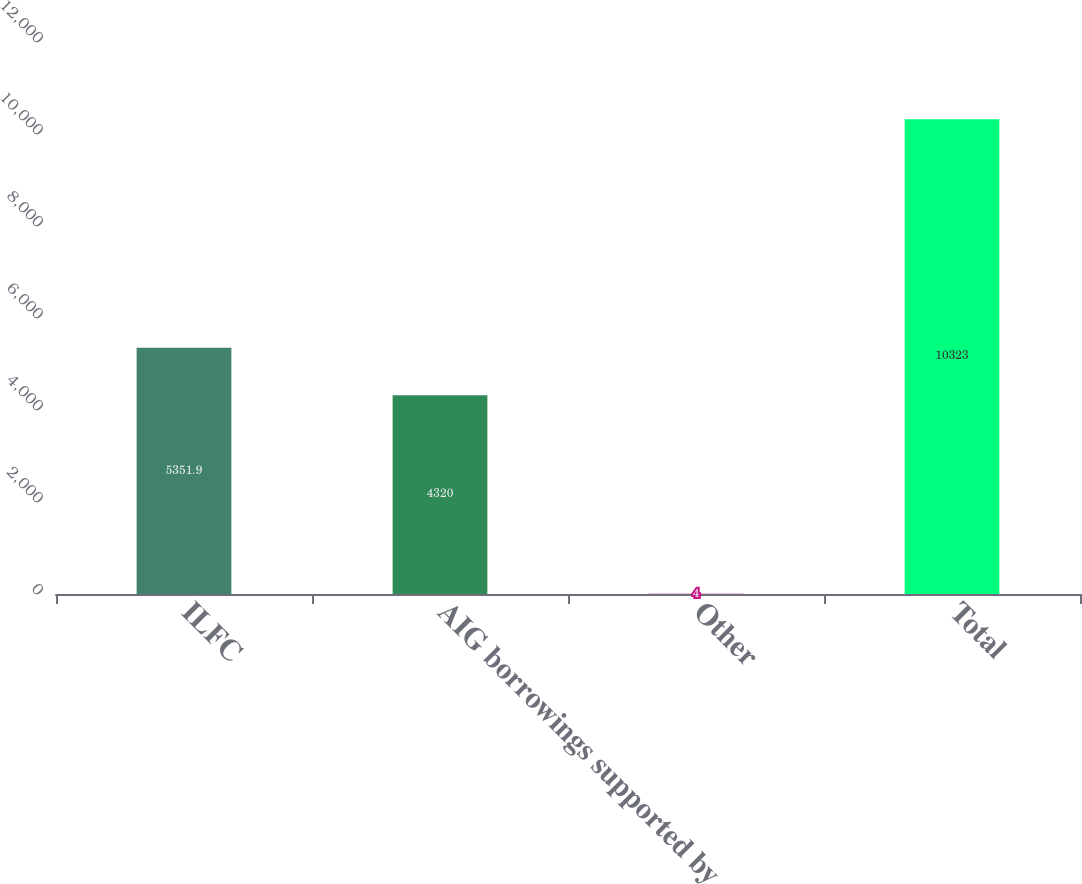Convert chart. <chart><loc_0><loc_0><loc_500><loc_500><bar_chart><fcel>ILFC<fcel>AIG borrowings supported by<fcel>Other<fcel>Total<nl><fcel>5351.9<fcel>4320<fcel>4<fcel>10323<nl></chart> 